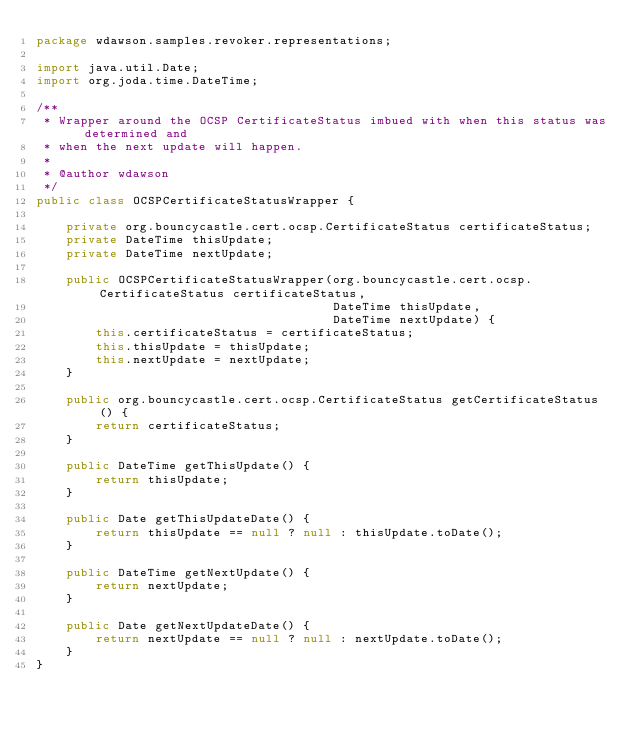Convert code to text. <code><loc_0><loc_0><loc_500><loc_500><_Java_>package wdawson.samples.revoker.representations;

import java.util.Date;
import org.joda.time.DateTime;

/**
 * Wrapper around the OCSP CertificateStatus imbued with when this status was determined and
 * when the next update will happen.
 *
 * @author wdawson
 */
public class OCSPCertificateStatusWrapper {

    private org.bouncycastle.cert.ocsp.CertificateStatus certificateStatus;
    private DateTime thisUpdate;
    private DateTime nextUpdate;

    public OCSPCertificateStatusWrapper(org.bouncycastle.cert.ocsp.CertificateStatus certificateStatus,
                                        DateTime thisUpdate,
                                        DateTime nextUpdate) {
        this.certificateStatus = certificateStatus;
        this.thisUpdate = thisUpdate;
        this.nextUpdate = nextUpdate;
    }

    public org.bouncycastle.cert.ocsp.CertificateStatus getCertificateStatus() {
        return certificateStatus;
    }

    public DateTime getThisUpdate() {
        return thisUpdate;
    }

    public Date getThisUpdateDate() {
        return thisUpdate == null ? null : thisUpdate.toDate();
    }

    public DateTime getNextUpdate() {
        return nextUpdate;
    }

    public Date getNextUpdateDate() {
        return nextUpdate == null ? null : nextUpdate.toDate();
    }
}
</code> 